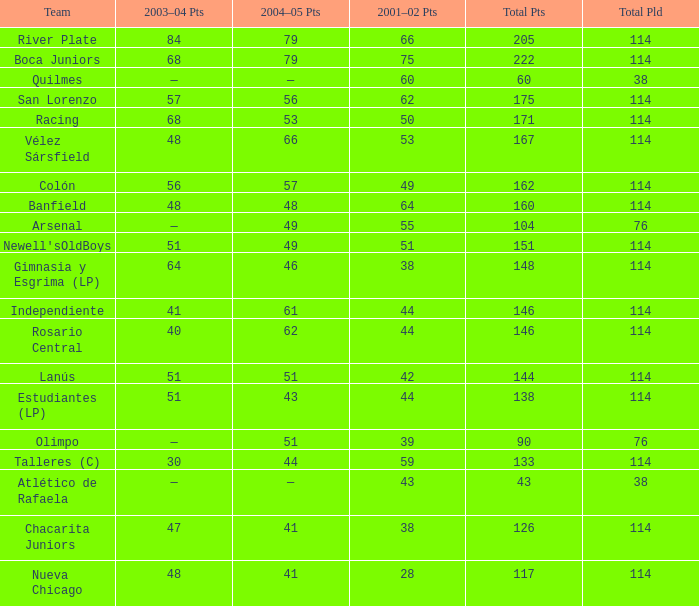Which Team has a Total Pld smaller than 114, and a 2004–05 Pts of 49? Arsenal. 